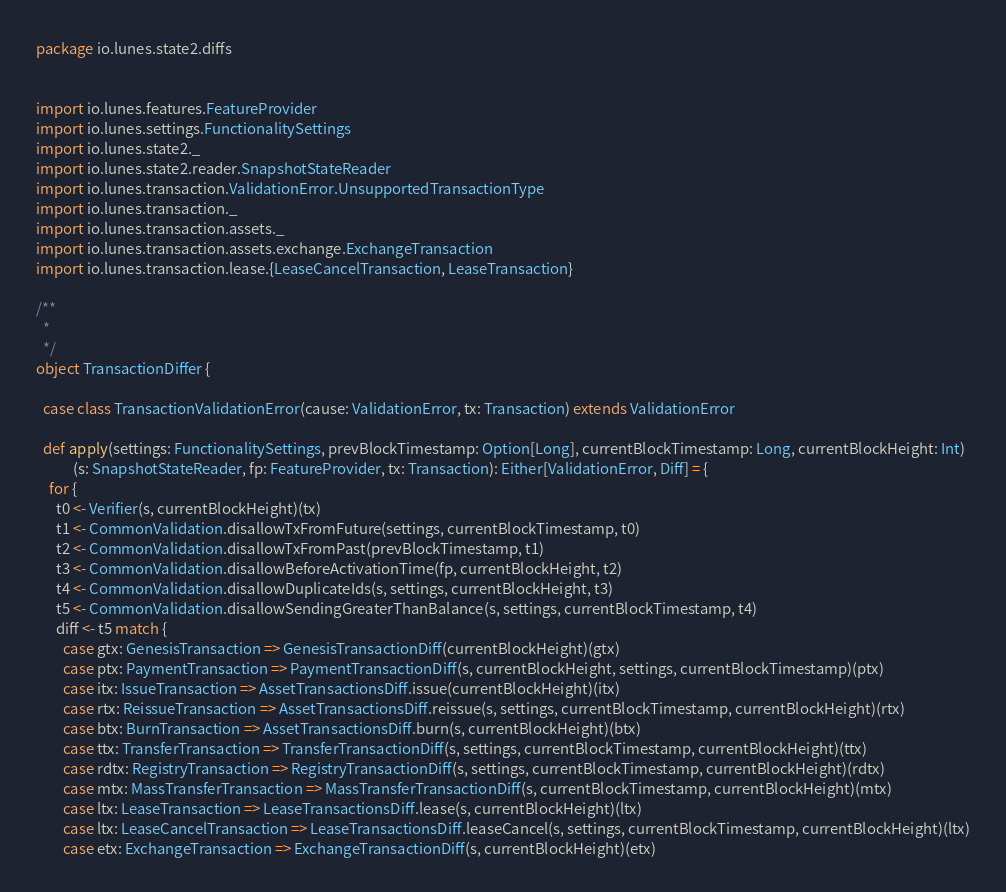Convert code to text. <code><loc_0><loc_0><loc_500><loc_500><_Scala_>package io.lunes.state2.diffs


import io.lunes.features.FeatureProvider
import io.lunes.settings.FunctionalitySettings
import io.lunes.state2._
import io.lunes.state2.reader.SnapshotStateReader
import io.lunes.transaction.ValidationError.UnsupportedTransactionType
import io.lunes.transaction._
import io.lunes.transaction.assets._
import io.lunes.transaction.assets.exchange.ExchangeTransaction
import io.lunes.transaction.lease.{LeaseCancelTransaction, LeaseTransaction}

/**
  *
  */
object TransactionDiffer {

  case class TransactionValidationError(cause: ValidationError, tx: Transaction) extends ValidationError

  def apply(settings: FunctionalitySettings, prevBlockTimestamp: Option[Long], currentBlockTimestamp: Long, currentBlockHeight: Int)
           (s: SnapshotStateReader, fp: FeatureProvider, tx: Transaction): Either[ValidationError, Diff] = {
    for {
      t0 <- Verifier(s, currentBlockHeight)(tx)
      t1 <- CommonValidation.disallowTxFromFuture(settings, currentBlockTimestamp, t0)
      t2 <- CommonValidation.disallowTxFromPast(prevBlockTimestamp, t1)
      t3 <- CommonValidation.disallowBeforeActivationTime(fp, currentBlockHeight, t2)
      t4 <- CommonValidation.disallowDuplicateIds(s, settings, currentBlockHeight, t3)
      t5 <- CommonValidation.disallowSendingGreaterThanBalance(s, settings, currentBlockTimestamp, t4)
      diff <- t5 match {
        case gtx: GenesisTransaction => GenesisTransactionDiff(currentBlockHeight)(gtx)
        case ptx: PaymentTransaction => PaymentTransactionDiff(s, currentBlockHeight, settings, currentBlockTimestamp)(ptx)
        case itx: IssueTransaction => AssetTransactionsDiff.issue(currentBlockHeight)(itx)
        case rtx: ReissueTransaction => AssetTransactionsDiff.reissue(s, settings, currentBlockTimestamp, currentBlockHeight)(rtx)
        case btx: BurnTransaction => AssetTransactionsDiff.burn(s, currentBlockHeight)(btx)
        case ttx: TransferTransaction => TransferTransactionDiff(s, settings, currentBlockTimestamp, currentBlockHeight)(ttx)
        case rdtx: RegistryTransaction => RegistryTransactionDiff(s, settings, currentBlockTimestamp, currentBlockHeight)(rdtx)
        case mtx: MassTransferTransaction => MassTransferTransactionDiff(s, currentBlockTimestamp, currentBlockHeight)(mtx)
        case ltx: LeaseTransaction => LeaseTransactionsDiff.lease(s, currentBlockHeight)(ltx)
        case ltx: LeaseCancelTransaction => LeaseTransactionsDiff.leaseCancel(s, settings, currentBlockTimestamp, currentBlockHeight)(ltx)
        case etx: ExchangeTransaction => ExchangeTransactionDiff(s, currentBlockHeight)(etx)</code> 